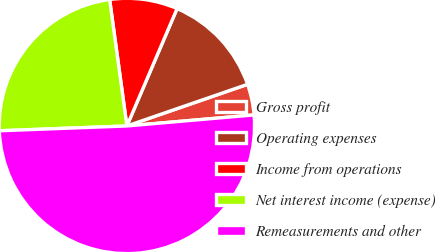<chart> <loc_0><loc_0><loc_500><loc_500><pie_chart><fcel>Gross profit<fcel>Operating expenses<fcel>Income from operations<fcel>Net interest income (expense)<fcel>Remeasurements and other<nl><fcel>3.91%<fcel>13.28%<fcel>8.59%<fcel>23.44%<fcel>50.78%<nl></chart> 